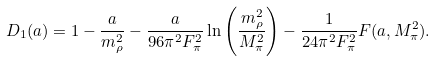Convert formula to latex. <formula><loc_0><loc_0><loc_500><loc_500>D _ { 1 } ( a ) = 1 - \frac { a } { m _ { \rho } ^ { 2 } } - \frac { a } { 9 6 \pi ^ { 2 } F _ { \pi } ^ { 2 } } \ln \left ( \frac { m _ { \rho } ^ { 2 } } { M _ { \pi } ^ { 2 } } \right ) - \frac { 1 } { 2 4 \pi ^ { 2 } F ^ { 2 } _ { \pi } } F ( a , M _ { \pi } ^ { 2 } ) .</formula> 